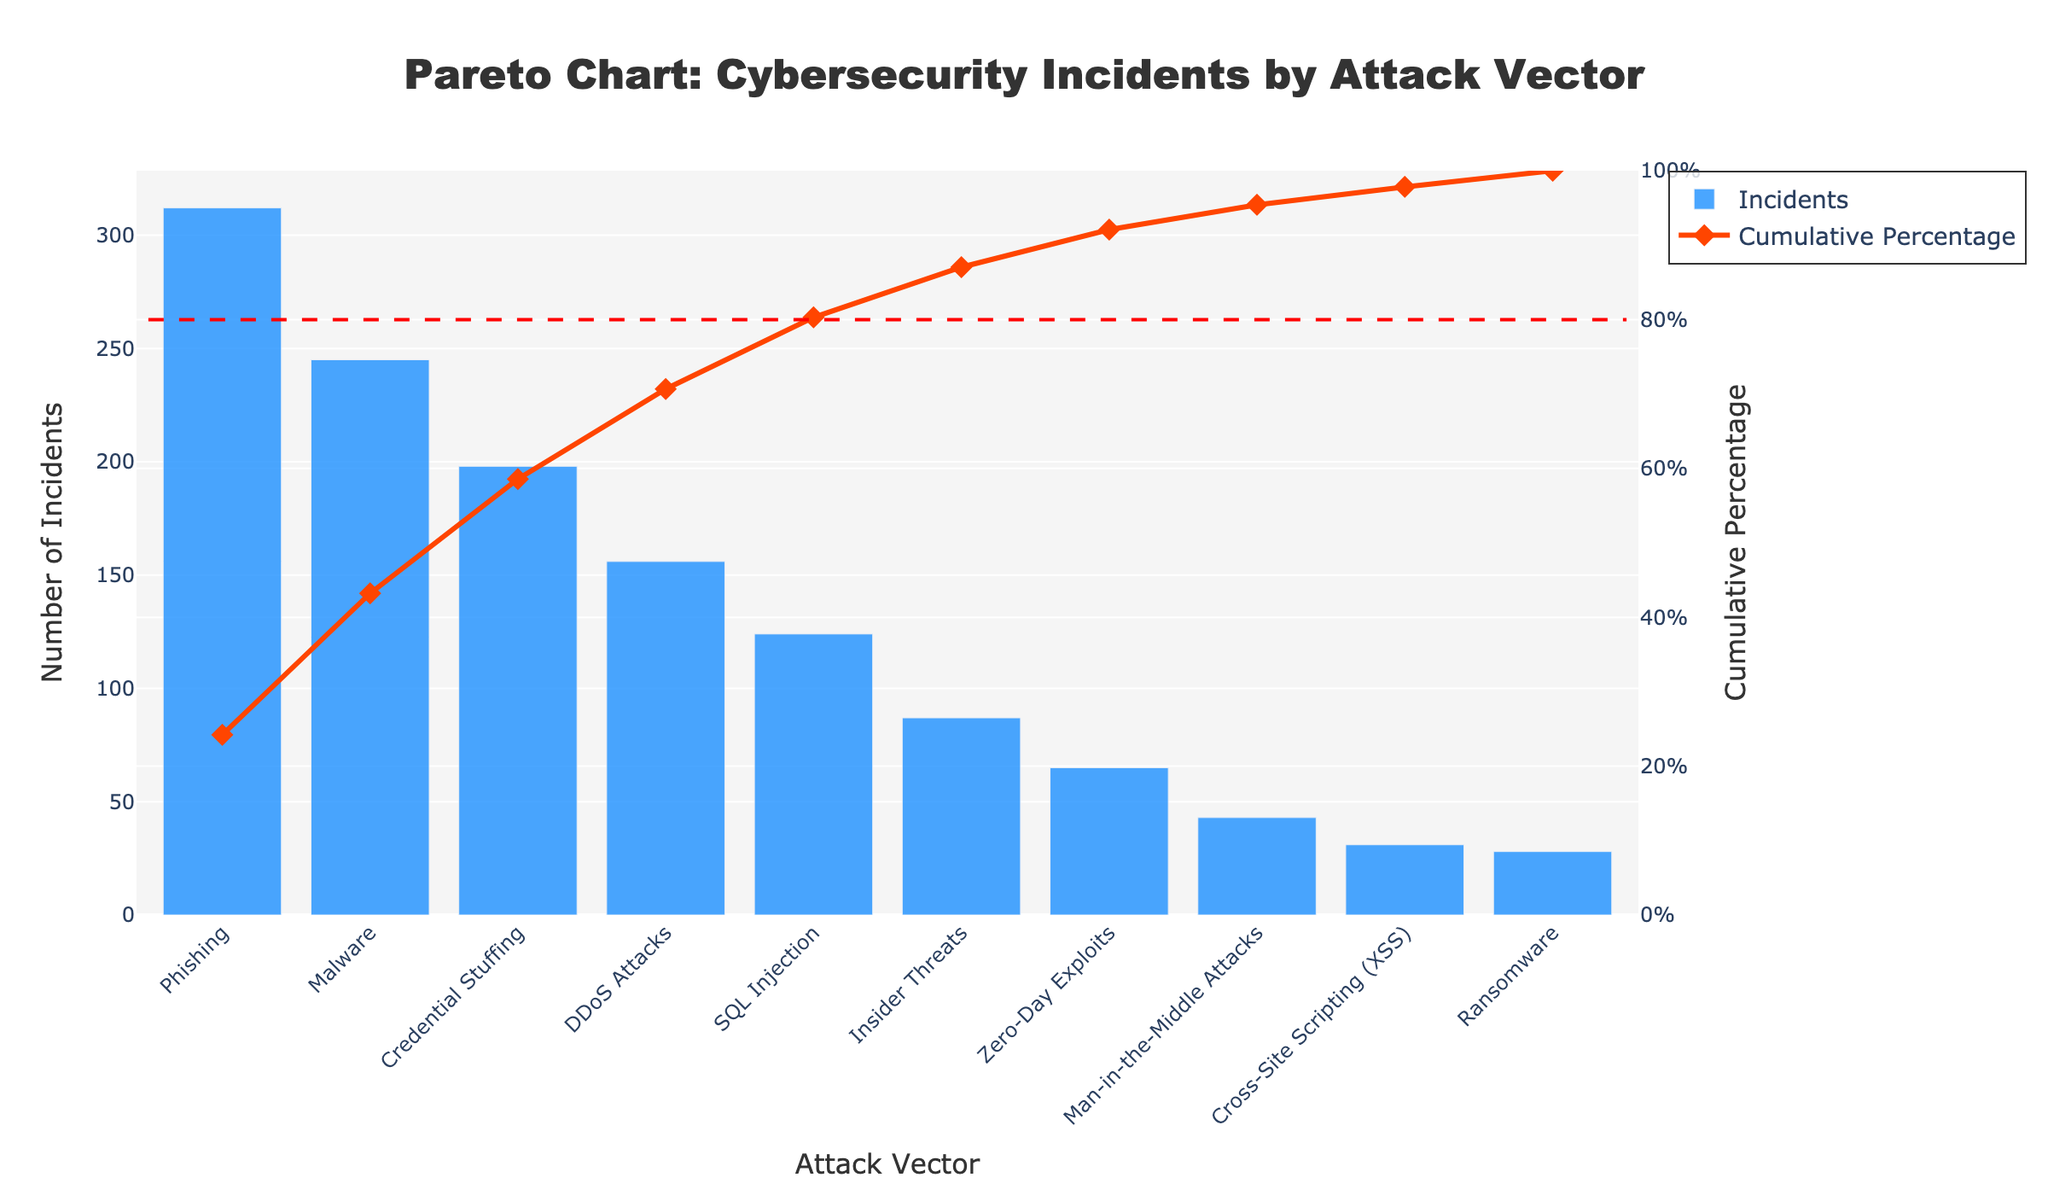What is the title of the Pareto chart? The title is displayed at the top of the chart and usually provides a summary of what the chart is about.
Answer: Pareto Chart: Cybersecurity Incidents by Attack Vector Which attack vector has the highest number of incidents? Look for the bar with the greatest height, which represents the highest number of incidents.
Answer: Phishing Which attack vectors together account for around 80% of the incidents? Identify the cumulative percentage line and see which attack vectors' bars together reach approximately 80% on the secondary y-axis.
Answer: Phishing, Malware, Credential Stuffing, DDoS Attacks, and SQL Injection What is the cumulative percentage for SQL Injection incidents? Trace the SQL Injection bar up to the red line marker (cumulative percentage line) and read the corresponding value on the secondary y-axis.
Answer: Approximately 82% How many incidents are associated with Man-in-the-Middle Attacks? Locate the bar labeled "Man-in-the-Middle Attacks" and read the height of the bar on the primary y-axis.
Answer: 43 What is the primary color used for the bars in the chart? Observe the color filling the bars representing the number of incidents.
Answer: Blue Which two attack vectors have the closest number of incidents? Compare the heights of the bars visually and identify the two that are most similar in height.
Answer: Cross-Site Scripting (XSS) and Ransomware What is the cumulative percentage just after DDoS Attacks? Identify the bar for DDoS Attacks and look at the cumulative percentage line right after it. Then, read the corresponding value on the secondary y-axis.
Answer: Slightly less than 65% Which attack vector has approximately half the number of incidents as Phishing? Compare the heights of the bars to identify the one that is about half the height of the Phishing bar.
Answer: Phishing has 312 incidents, so look for approximately 156 incidents, which is DDoS Attacks How many attack vectors are represented in the chart? Count all the labeled bars on the horizontal axis.
Answer: 10 